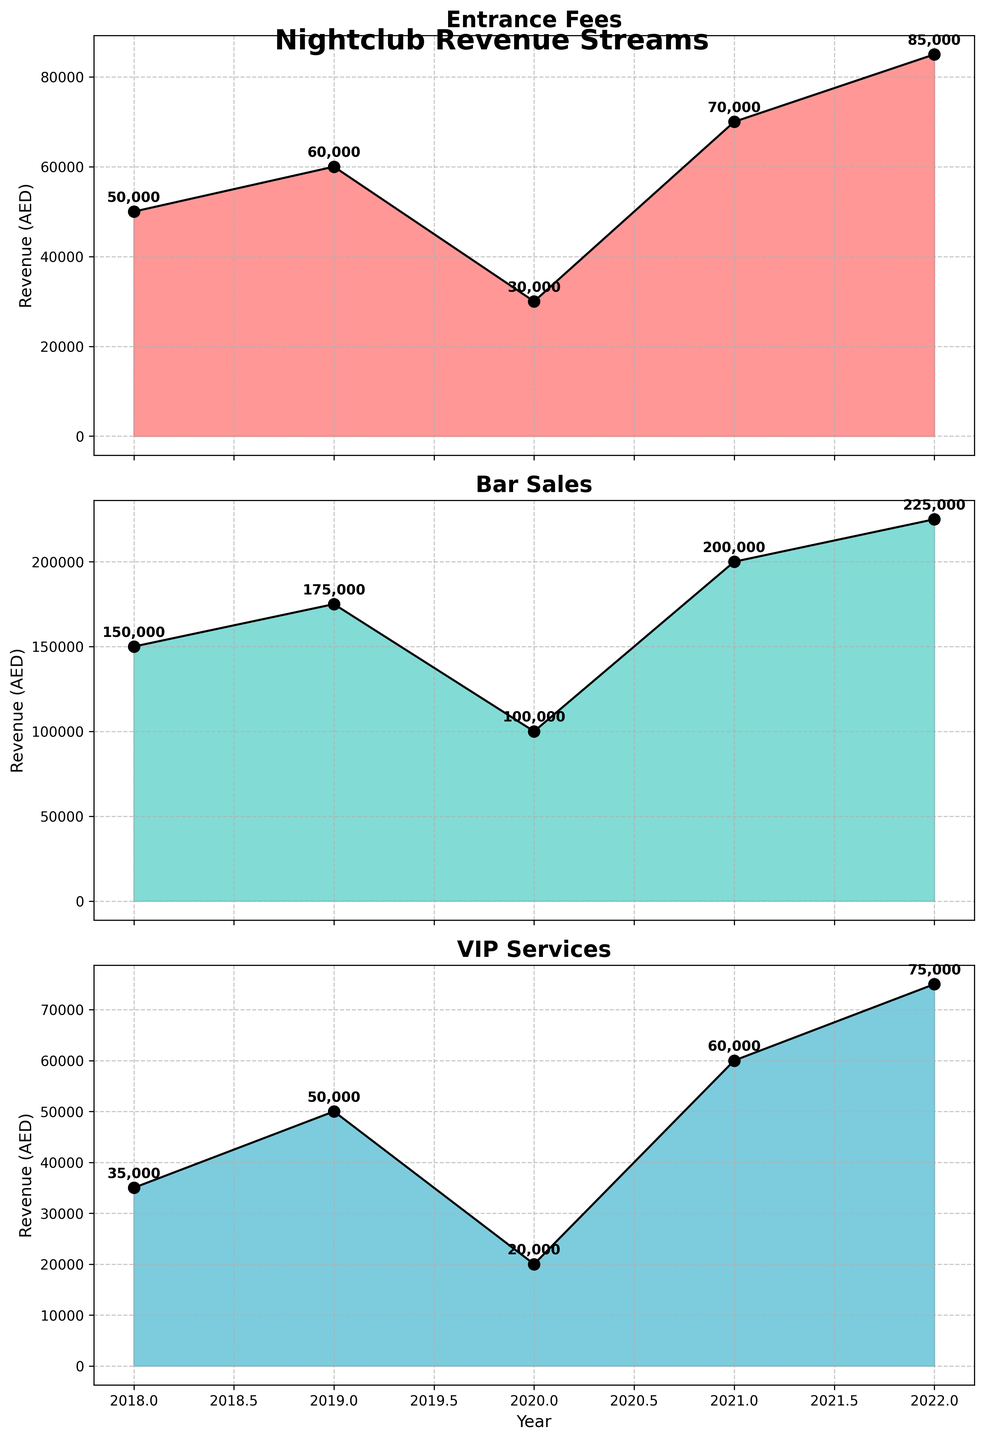What's the overall trend in entrance fees from 2018 to 2022? The area chart for entrance fees shows a rise from 2018 to 2019, a dip in 2020, and a steady increase from 2021 to 2022. Overall, the trend is upward.
Answer: Upward During which year did bar sales experience the biggest increase? Bar sales increased each year, but the year with the largest increase appears to be from 2020 to 2021, where it rose from 100,000 AED to 200,000 AED.
Answer: 2021 How did VIP services revenue change between 2020 and 2021? VIP services revenue increased from 20,000 AED in 2020 to 60,000 AED in 2021.
Answer: Increased What's the combined revenue from entrance fees, bar sales, and VIP services in 2022? The combined revenue for 2022 can be calculated by summing the values of entrance fees (85,000 AED), bar sales (225,000 AED), and VIP services (75,000 AED), which equals 385,000 AED.
Answer: 385,000 AED Which revenue stream experienced the most significant drop, and when did this happen? Entrance fees showed a significant drop from 60,000 AED in 2019 to 30,000 AED in 2020.
Answer: Entrance fees, in 2020 Compare the total revenue from VIP services in 2018 and 2019. Which year had higher revenue? VIP services revenue was 35,000 AED in 2018 and 50,000 AED in 2019. 2019 had higher revenue.
Answer: 2019 What was the total revenue from bar sales over the five years? Adding up bar sales from each year: 150,000 AED (2018) + 175,000 AED (2019) + 100,000 AED (2020) + 200,000 AED (2021) + 225,000 AED (2022) gives a total of 850,000 AED.
Answer: 850,000 AED What year had the lowest revenue for entrance fees, and what was the amount? The year 2020 had the lowest revenue for entrance fees, which was 30,000 AED.
Answer: 2020, 30,000 AED What's the difference in VIP services revenue between 2019 and 2022? Subtracting VIP services revenue in 2019 (50,000 AED) from 2022 (75,000 AED) gives a difference of 25,000 AED.
Answer: 25,000 AED Which revenue stream had the highest amount in 2021? In 2021, bar sales had the highest revenue amounting to 200,000 AED.
Answer: Bar sales 